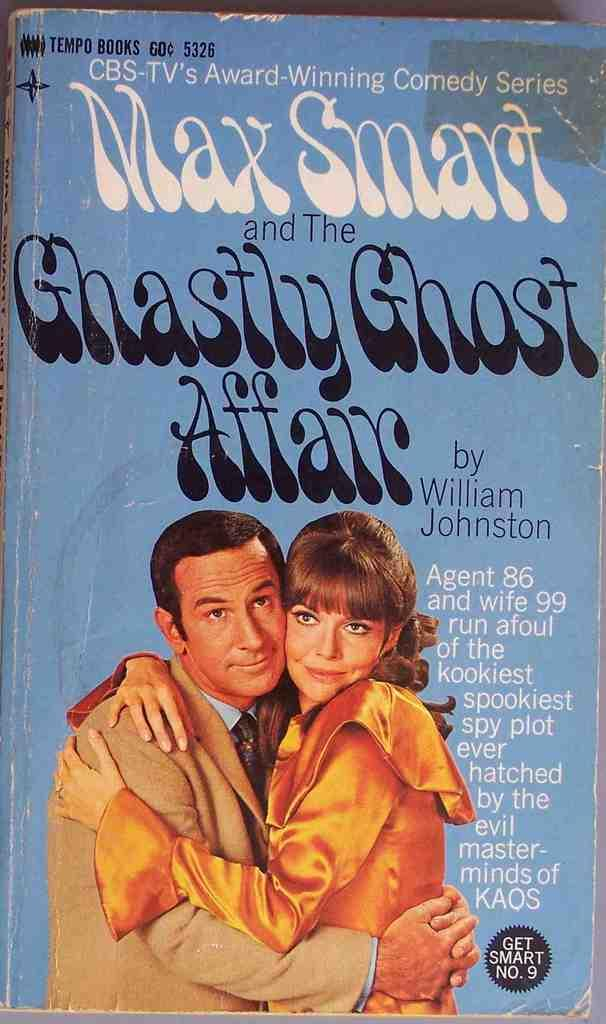<image>
Provide a brief description of the given image. The characters of Agent 86 and Agent 99 are featured on the cover of a Get Smart paperback tie-in. 